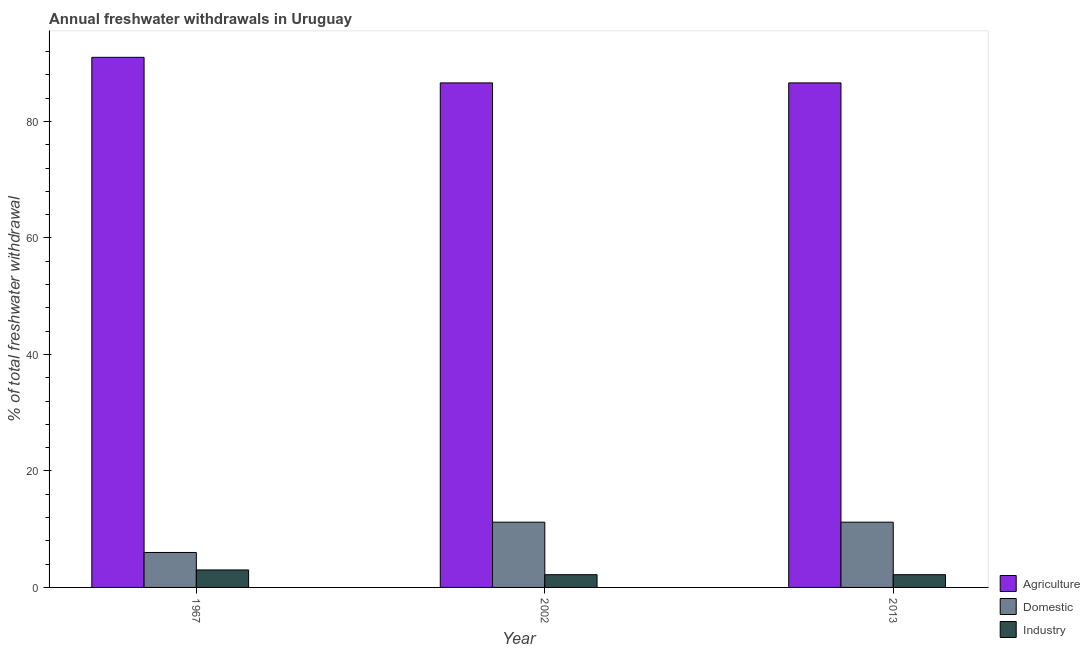How many groups of bars are there?
Your response must be concise. 3. What is the label of the 2nd group of bars from the left?
Your answer should be compact. 2002. What is the percentage of freshwater withdrawal for agriculture in 1967?
Provide a succinct answer. 91. Across all years, what is the maximum percentage of freshwater withdrawal for agriculture?
Keep it short and to the point. 91. Across all years, what is the minimum percentage of freshwater withdrawal for agriculture?
Give a very brief answer. 86.61. In which year was the percentage of freshwater withdrawal for industry maximum?
Offer a terse response. 1967. In which year was the percentage of freshwater withdrawal for agriculture minimum?
Provide a short and direct response. 2002. What is the total percentage of freshwater withdrawal for domestic purposes in the graph?
Your answer should be compact. 28.4. What is the difference between the percentage of freshwater withdrawal for industry in 1967 and that in 2002?
Provide a short and direct response. 0.81. What is the average percentage of freshwater withdrawal for agriculture per year?
Your response must be concise. 88.07. In the year 1967, what is the difference between the percentage of freshwater withdrawal for domestic purposes and percentage of freshwater withdrawal for industry?
Your response must be concise. 0. In how many years, is the percentage of freshwater withdrawal for agriculture greater than 60 %?
Your answer should be very brief. 3. What is the ratio of the percentage of freshwater withdrawal for agriculture in 2002 to that in 2013?
Provide a succinct answer. 1. Is the difference between the percentage of freshwater withdrawal for industry in 1967 and 2013 greater than the difference between the percentage of freshwater withdrawal for agriculture in 1967 and 2013?
Ensure brevity in your answer.  No. What is the difference between the highest and the second highest percentage of freshwater withdrawal for domestic purposes?
Your answer should be compact. 0. What is the difference between the highest and the lowest percentage of freshwater withdrawal for industry?
Provide a short and direct response. 0.81. What does the 3rd bar from the left in 2002 represents?
Offer a terse response. Industry. What does the 3rd bar from the right in 2013 represents?
Keep it short and to the point. Agriculture. Are all the bars in the graph horizontal?
Give a very brief answer. No. How many years are there in the graph?
Offer a terse response. 3. What is the difference between two consecutive major ticks on the Y-axis?
Provide a short and direct response. 20. Are the values on the major ticks of Y-axis written in scientific E-notation?
Offer a very short reply. No. Does the graph contain any zero values?
Your answer should be very brief. No. Does the graph contain grids?
Your response must be concise. No. What is the title of the graph?
Ensure brevity in your answer.  Annual freshwater withdrawals in Uruguay. What is the label or title of the Y-axis?
Your response must be concise. % of total freshwater withdrawal. What is the % of total freshwater withdrawal in Agriculture in 1967?
Your answer should be very brief. 91. What is the % of total freshwater withdrawal in Domestic in 1967?
Provide a short and direct response. 6. What is the % of total freshwater withdrawal of Agriculture in 2002?
Provide a succinct answer. 86.61. What is the % of total freshwater withdrawal of Industry in 2002?
Provide a short and direct response. 2.19. What is the % of total freshwater withdrawal of Agriculture in 2013?
Your answer should be compact. 86.61. What is the % of total freshwater withdrawal of Industry in 2013?
Ensure brevity in your answer.  2.19. Across all years, what is the maximum % of total freshwater withdrawal in Agriculture?
Offer a terse response. 91. Across all years, what is the maximum % of total freshwater withdrawal of Industry?
Give a very brief answer. 3. Across all years, what is the minimum % of total freshwater withdrawal in Agriculture?
Offer a very short reply. 86.61. Across all years, what is the minimum % of total freshwater withdrawal of Domestic?
Your answer should be very brief. 6. Across all years, what is the minimum % of total freshwater withdrawal of Industry?
Your response must be concise. 2.19. What is the total % of total freshwater withdrawal of Agriculture in the graph?
Your answer should be compact. 264.22. What is the total % of total freshwater withdrawal in Domestic in the graph?
Provide a succinct answer. 28.4. What is the total % of total freshwater withdrawal of Industry in the graph?
Your answer should be very brief. 7.37. What is the difference between the % of total freshwater withdrawal in Agriculture in 1967 and that in 2002?
Keep it short and to the point. 4.39. What is the difference between the % of total freshwater withdrawal in Domestic in 1967 and that in 2002?
Make the answer very short. -5.2. What is the difference between the % of total freshwater withdrawal in Industry in 1967 and that in 2002?
Give a very brief answer. 0.81. What is the difference between the % of total freshwater withdrawal in Agriculture in 1967 and that in 2013?
Provide a succinct answer. 4.39. What is the difference between the % of total freshwater withdrawal in Domestic in 1967 and that in 2013?
Make the answer very short. -5.2. What is the difference between the % of total freshwater withdrawal of Industry in 1967 and that in 2013?
Provide a succinct answer. 0.81. What is the difference between the % of total freshwater withdrawal of Agriculture in 2002 and that in 2013?
Give a very brief answer. 0. What is the difference between the % of total freshwater withdrawal of Agriculture in 1967 and the % of total freshwater withdrawal of Domestic in 2002?
Provide a short and direct response. 79.8. What is the difference between the % of total freshwater withdrawal of Agriculture in 1967 and the % of total freshwater withdrawal of Industry in 2002?
Make the answer very short. 88.81. What is the difference between the % of total freshwater withdrawal in Domestic in 1967 and the % of total freshwater withdrawal in Industry in 2002?
Your answer should be compact. 3.81. What is the difference between the % of total freshwater withdrawal of Agriculture in 1967 and the % of total freshwater withdrawal of Domestic in 2013?
Your response must be concise. 79.8. What is the difference between the % of total freshwater withdrawal of Agriculture in 1967 and the % of total freshwater withdrawal of Industry in 2013?
Give a very brief answer. 88.81. What is the difference between the % of total freshwater withdrawal of Domestic in 1967 and the % of total freshwater withdrawal of Industry in 2013?
Your response must be concise. 3.81. What is the difference between the % of total freshwater withdrawal of Agriculture in 2002 and the % of total freshwater withdrawal of Domestic in 2013?
Your answer should be very brief. 75.41. What is the difference between the % of total freshwater withdrawal of Agriculture in 2002 and the % of total freshwater withdrawal of Industry in 2013?
Your answer should be very brief. 84.42. What is the difference between the % of total freshwater withdrawal of Domestic in 2002 and the % of total freshwater withdrawal of Industry in 2013?
Offer a very short reply. 9.01. What is the average % of total freshwater withdrawal in Agriculture per year?
Provide a succinct answer. 88.07. What is the average % of total freshwater withdrawal in Domestic per year?
Provide a short and direct response. 9.47. What is the average % of total freshwater withdrawal of Industry per year?
Provide a succinct answer. 2.46. In the year 1967, what is the difference between the % of total freshwater withdrawal of Domestic and % of total freshwater withdrawal of Industry?
Your answer should be compact. 3. In the year 2002, what is the difference between the % of total freshwater withdrawal of Agriculture and % of total freshwater withdrawal of Domestic?
Offer a very short reply. 75.41. In the year 2002, what is the difference between the % of total freshwater withdrawal in Agriculture and % of total freshwater withdrawal in Industry?
Ensure brevity in your answer.  84.42. In the year 2002, what is the difference between the % of total freshwater withdrawal in Domestic and % of total freshwater withdrawal in Industry?
Keep it short and to the point. 9.01. In the year 2013, what is the difference between the % of total freshwater withdrawal in Agriculture and % of total freshwater withdrawal in Domestic?
Offer a terse response. 75.41. In the year 2013, what is the difference between the % of total freshwater withdrawal of Agriculture and % of total freshwater withdrawal of Industry?
Offer a terse response. 84.42. In the year 2013, what is the difference between the % of total freshwater withdrawal in Domestic and % of total freshwater withdrawal in Industry?
Your answer should be very brief. 9.01. What is the ratio of the % of total freshwater withdrawal in Agriculture in 1967 to that in 2002?
Provide a succinct answer. 1.05. What is the ratio of the % of total freshwater withdrawal of Domestic in 1967 to that in 2002?
Make the answer very short. 0.54. What is the ratio of the % of total freshwater withdrawal in Industry in 1967 to that in 2002?
Give a very brief answer. 1.37. What is the ratio of the % of total freshwater withdrawal in Agriculture in 1967 to that in 2013?
Ensure brevity in your answer.  1.05. What is the ratio of the % of total freshwater withdrawal in Domestic in 1967 to that in 2013?
Make the answer very short. 0.54. What is the ratio of the % of total freshwater withdrawal in Industry in 1967 to that in 2013?
Offer a terse response. 1.37. What is the ratio of the % of total freshwater withdrawal of Agriculture in 2002 to that in 2013?
Offer a very short reply. 1. What is the ratio of the % of total freshwater withdrawal in Domestic in 2002 to that in 2013?
Your answer should be very brief. 1. What is the ratio of the % of total freshwater withdrawal of Industry in 2002 to that in 2013?
Offer a terse response. 1. What is the difference between the highest and the second highest % of total freshwater withdrawal in Agriculture?
Ensure brevity in your answer.  4.39. What is the difference between the highest and the second highest % of total freshwater withdrawal in Domestic?
Provide a succinct answer. 0. What is the difference between the highest and the second highest % of total freshwater withdrawal in Industry?
Provide a succinct answer. 0.81. What is the difference between the highest and the lowest % of total freshwater withdrawal of Agriculture?
Ensure brevity in your answer.  4.39. What is the difference between the highest and the lowest % of total freshwater withdrawal of Domestic?
Your response must be concise. 5.2. What is the difference between the highest and the lowest % of total freshwater withdrawal of Industry?
Offer a terse response. 0.81. 